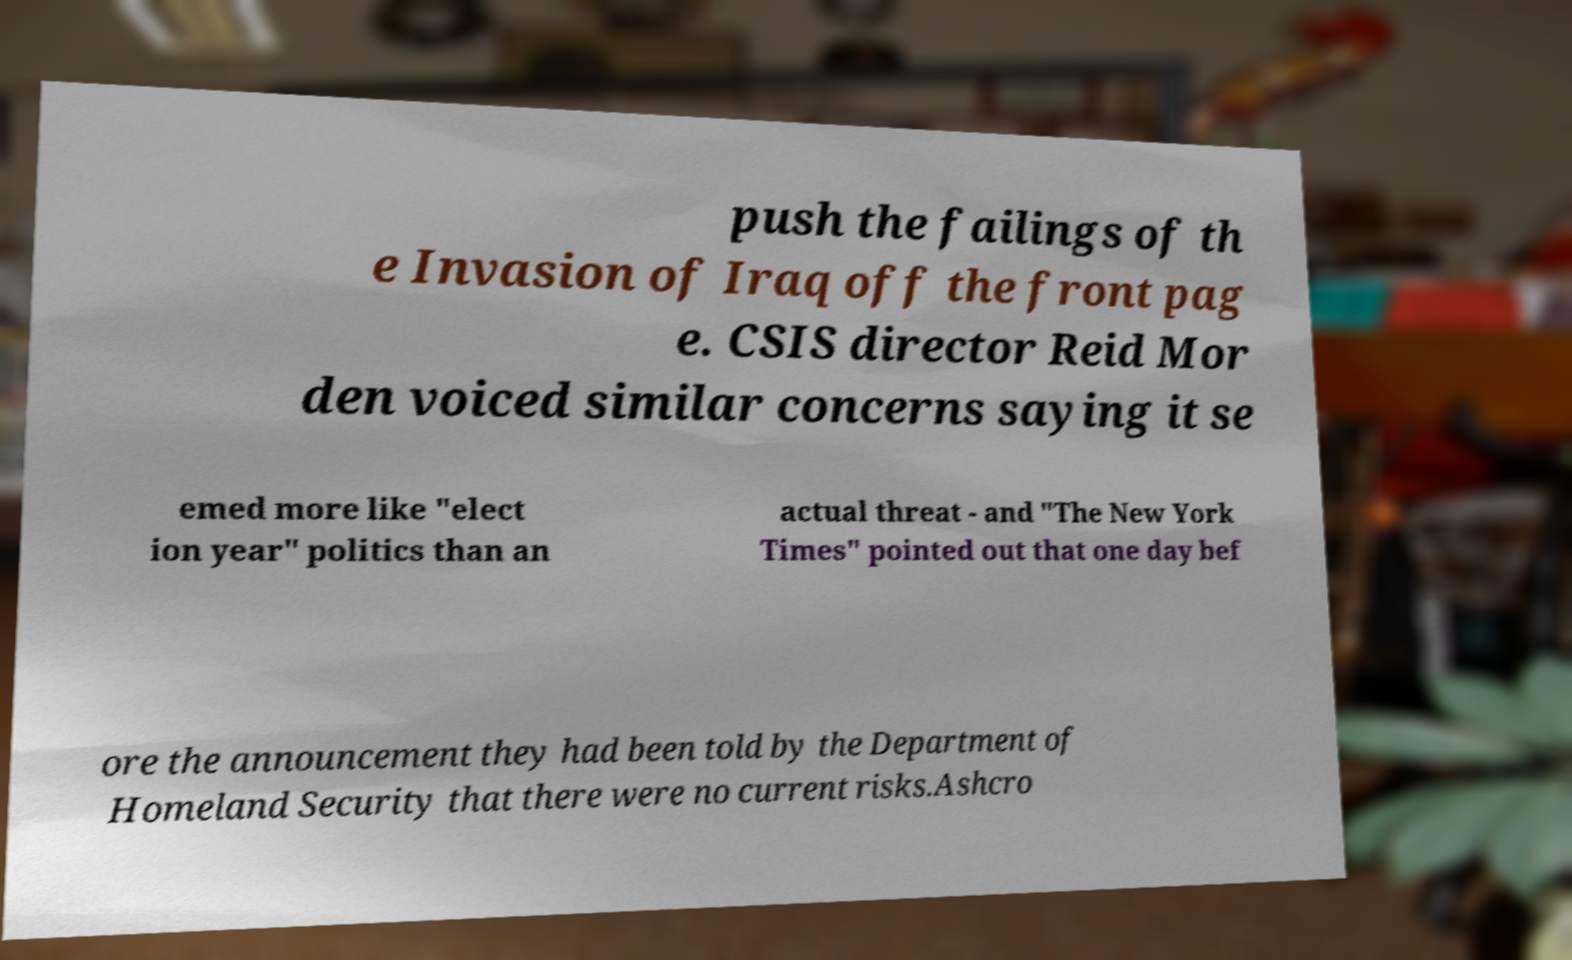Please read and relay the text visible in this image. What does it say? push the failings of th e Invasion of Iraq off the front pag e. CSIS director Reid Mor den voiced similar concerns saying it se emed more like "elect ion year" politics than an actual threat - and "The New York Times" pointed out that one day bef ore the announcement they had been told by the Department of Homeland Security that there were no current risks.Ashcro 